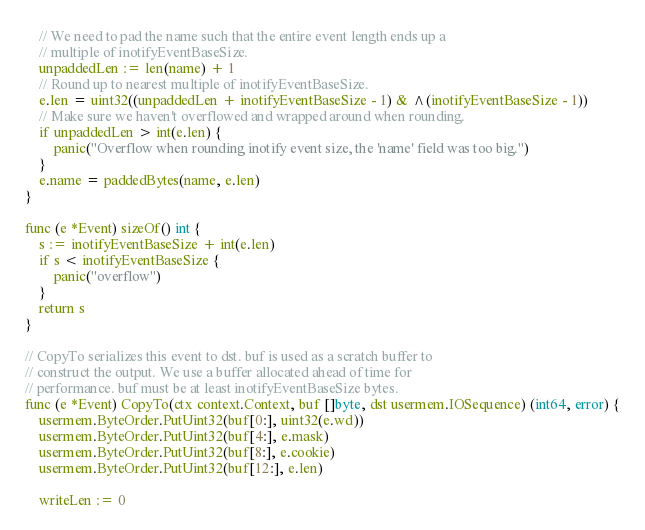<code> <loc_0><loc_0><loc_500><loc_500><_Go_>	// We need to pad the name such that the entire event length ends up a
	// multiple of inotifyEventBaseSize.
	unpaddedLen := len(name) + 1
	// Round up to nearest multiple of inotifyEventBaseSize.
	e.len = uint32((unpaddedLen + inotifyEventBaseSize - 1) & ^(inotifyEventBaseSize - 1))
	// Make sure we haven't overflowed and wrapped around when rounding.
	if unpaddedLen > int(e.len) {
		panic("Overflow when rounding inotify event size, the 'name' field was too big.")
	}
	e.name = paddedBytes(name, e.len)
}

func (e *Event) sizeOf() int {
	s := inotifyEventBaseSize + int(e.len)
	if s < inotifyEventBaseSize {
		panic("overflow")
	}
	return s
}

// CopyTo serializes this event to dst. buf is used as a scratch buffer to
// construct the output. We use a buffer allocated ahead of time for
// performance. buf must be at least inotifyEventBaseSize bytes.
func (e *Event) CopyTo(ctx context.Context, buf []byte, dst usermem.IOSequence) (int64, error) {
	usermem.ByteOrder.PutUint32(buf[0:], uint32(e.wd))
	usermem.ByteOrder.PutUint32(buf[4:], e.mask)
	usermem.ByteOrder.PutUint32(buf[8:], e.cookie)
	usermem.ByteOrder.PutUint32(buf[12:], e.len)

	writeLen := 0
</code> 